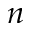Convert formula to latex. <formula><loc_0><loc_0><loc_500><loc_500>n</formula> 